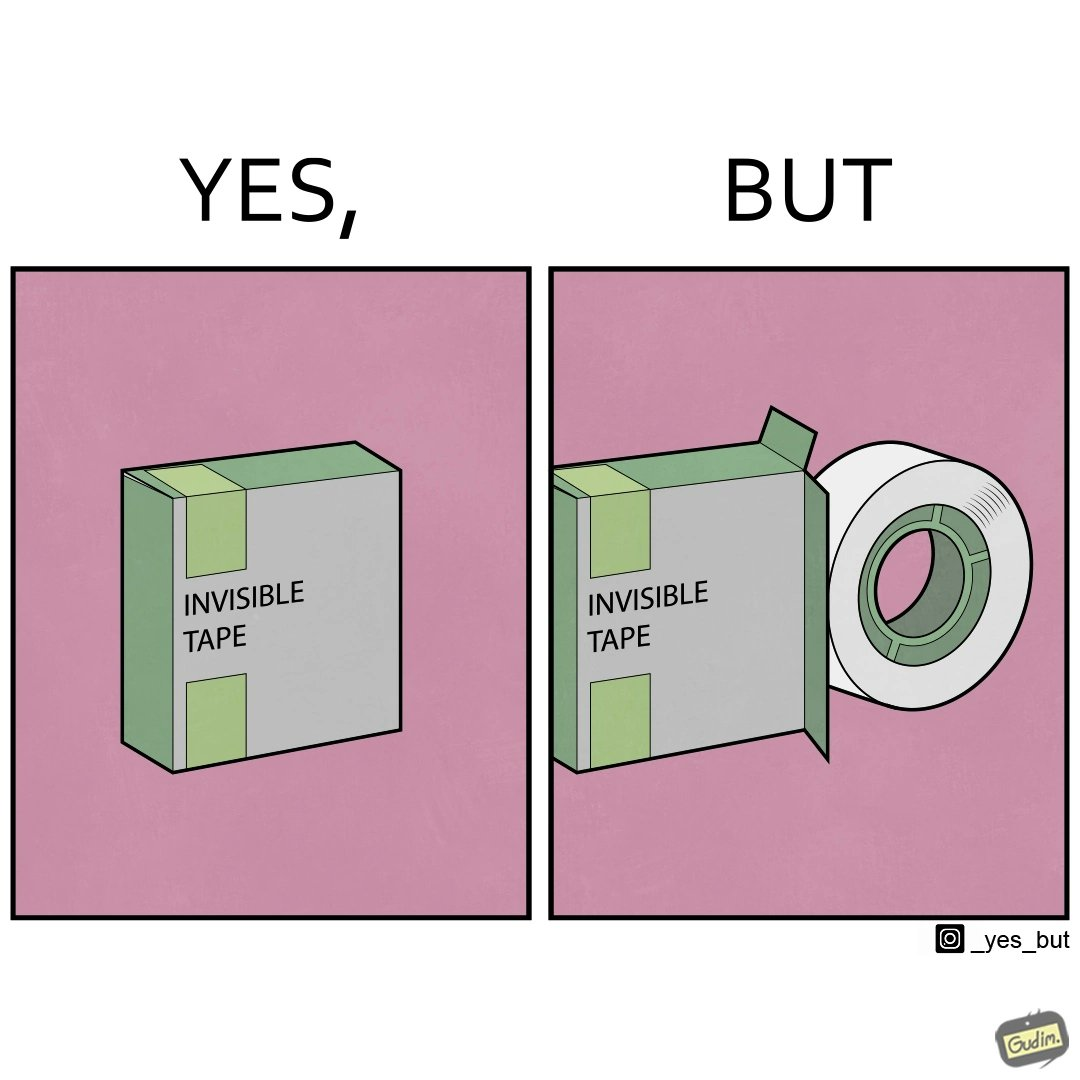Is there satirical content in this image? Yes, this image is satirical. 